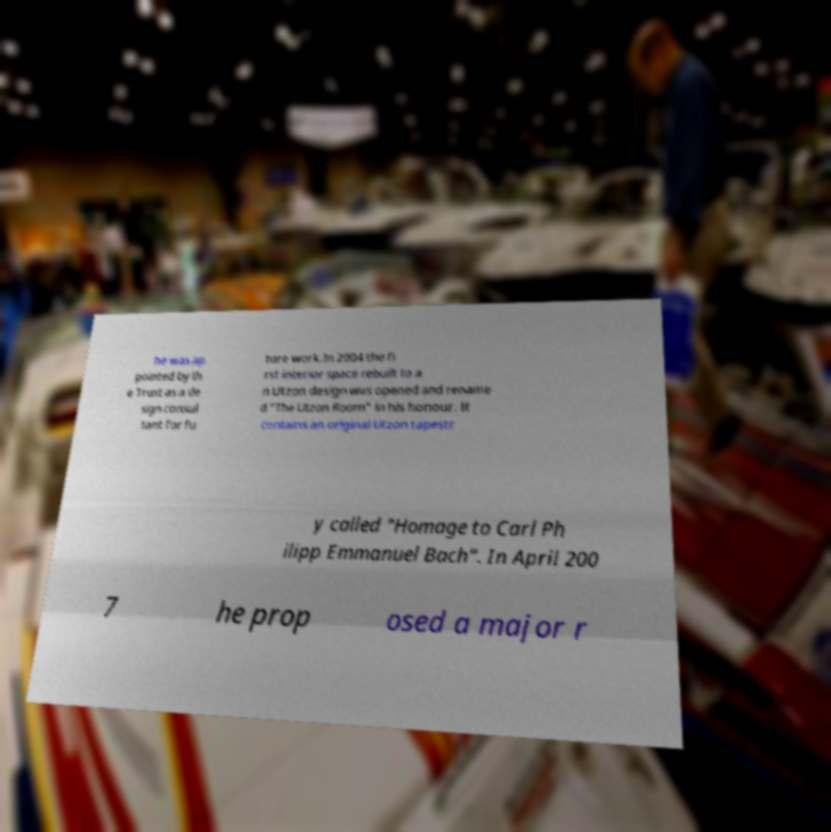There's text embedded in this image that I need extracted. Can you transcribe it verbatim? he was ap pointed by th e Trust as a de sign consul tant for fu ture work.In 2004 the fi rst interior space rebuilt to a n Utzon design was opened and rename d "The Utzon Room" in his honour. It contains an original Utzon tapestr y called "Homage to Carl Ph ilipp Emmanuel Bach". In April 200 7 he prop osed a major r 